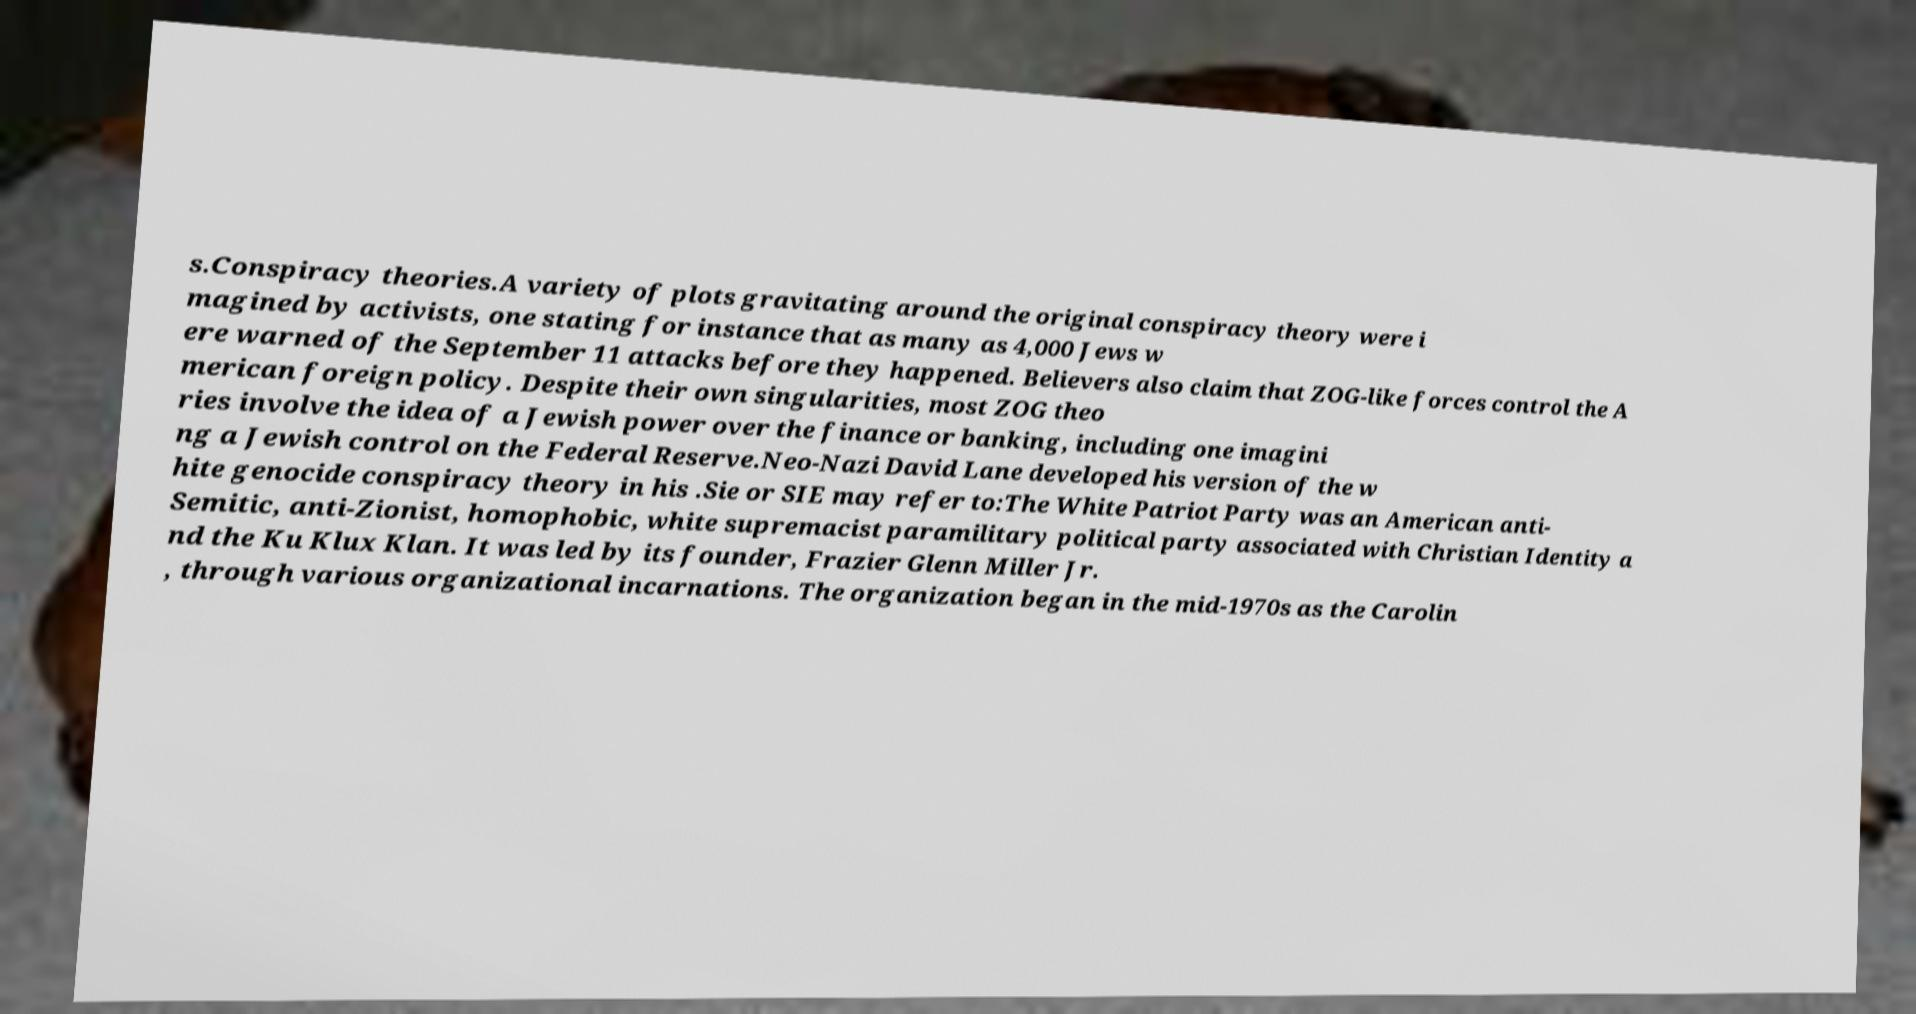Could you extract and type out the text from this image? s.Conspiracy theories.A variety of plots gravitating around the original conspiracy theory were i magined by activists, one stating for instance that as many as 4,000 Jews w ere warned of the September 11 attacks before they happened. Believers also claim that ZOG-like forces control the A merican foreign policy. Despite their own singularities, most ZOG theo ries involve the idea of a Jewish power over the finance or banking, including one imagini ng a Jewish control on the Federal Reserve.Neo-Nazi David Lane developed his version of the w hite genocide conspiracy theory in his .Sie or SIE may refer to:The White Patriot Party was an American anti- Semitic, anti-Zionist, homophobic, white supremacist paramilitary political party associated with Christian Identity a nd the Ku Klux Klan. It was led by its founder, Frazier Glenn Miller Jr. , through various organizational incarnations. The organization began in the mid-1970s as the Carolin 